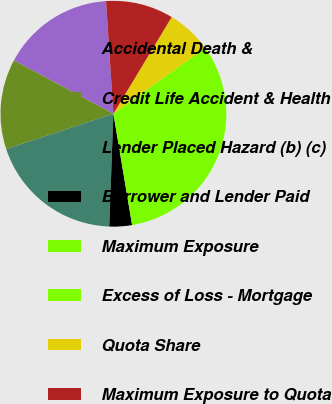Convert chart to OTSL. <chart><loc_0><loc_0><loc_500><loc_500><pie_chart><fcel>Accidental Death &<fcel>Credit Life Accident & Health<fcel>Lender Placed Hazard (b) (c)<fcel>Borrower and Lender Paid<fcel>Maximum Exposure<fcel>Excess of Loss - Mortgage<fcel>Quota Share<fcel>Maximum Exposure to Quota<nl><fcel>16.13%<fcel>12.9%<fcel>19.35%<fcel>3.23%<fcel>32.25%<fcel>0.01%<fcel>6.46%<fcel>9.68%<nl></chart> 